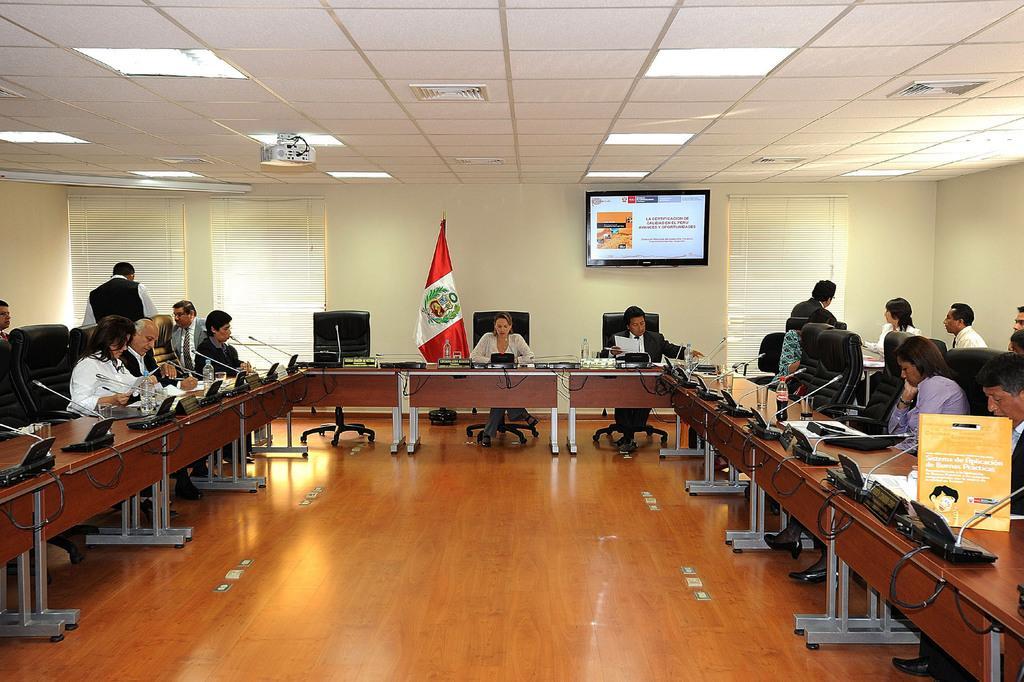Describe this image in one or two sentences. In this image i can see few people sitting on chairs and a flag. In the background i can see a wall, a window blind, a person standing and a television screen. 